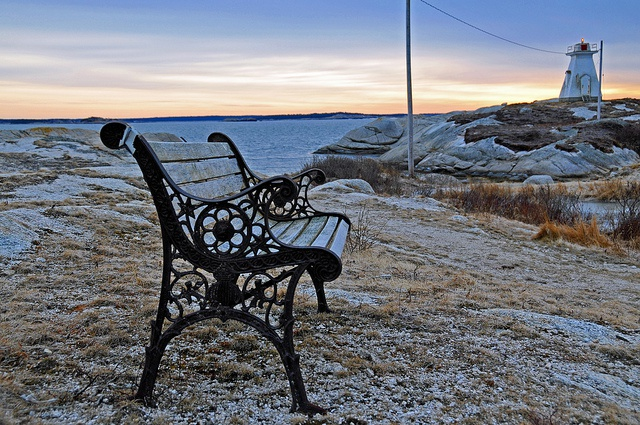Describe the objects in this image and their specific colors. I can see a bench in darkgray, black, and gray tones in this image. 